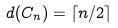<formula> <loc_0><loc_0><loc_500><loc_500>d ( C _ { n } ) = \lceil n / 2 \rceil</formula> 